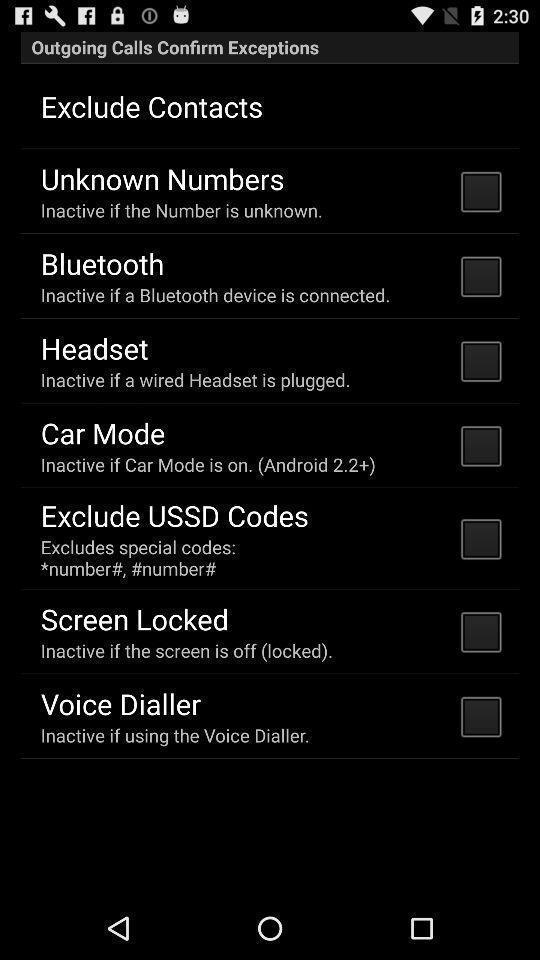Provide a detailed account of this screenshot. Screen displaying list of settings. 